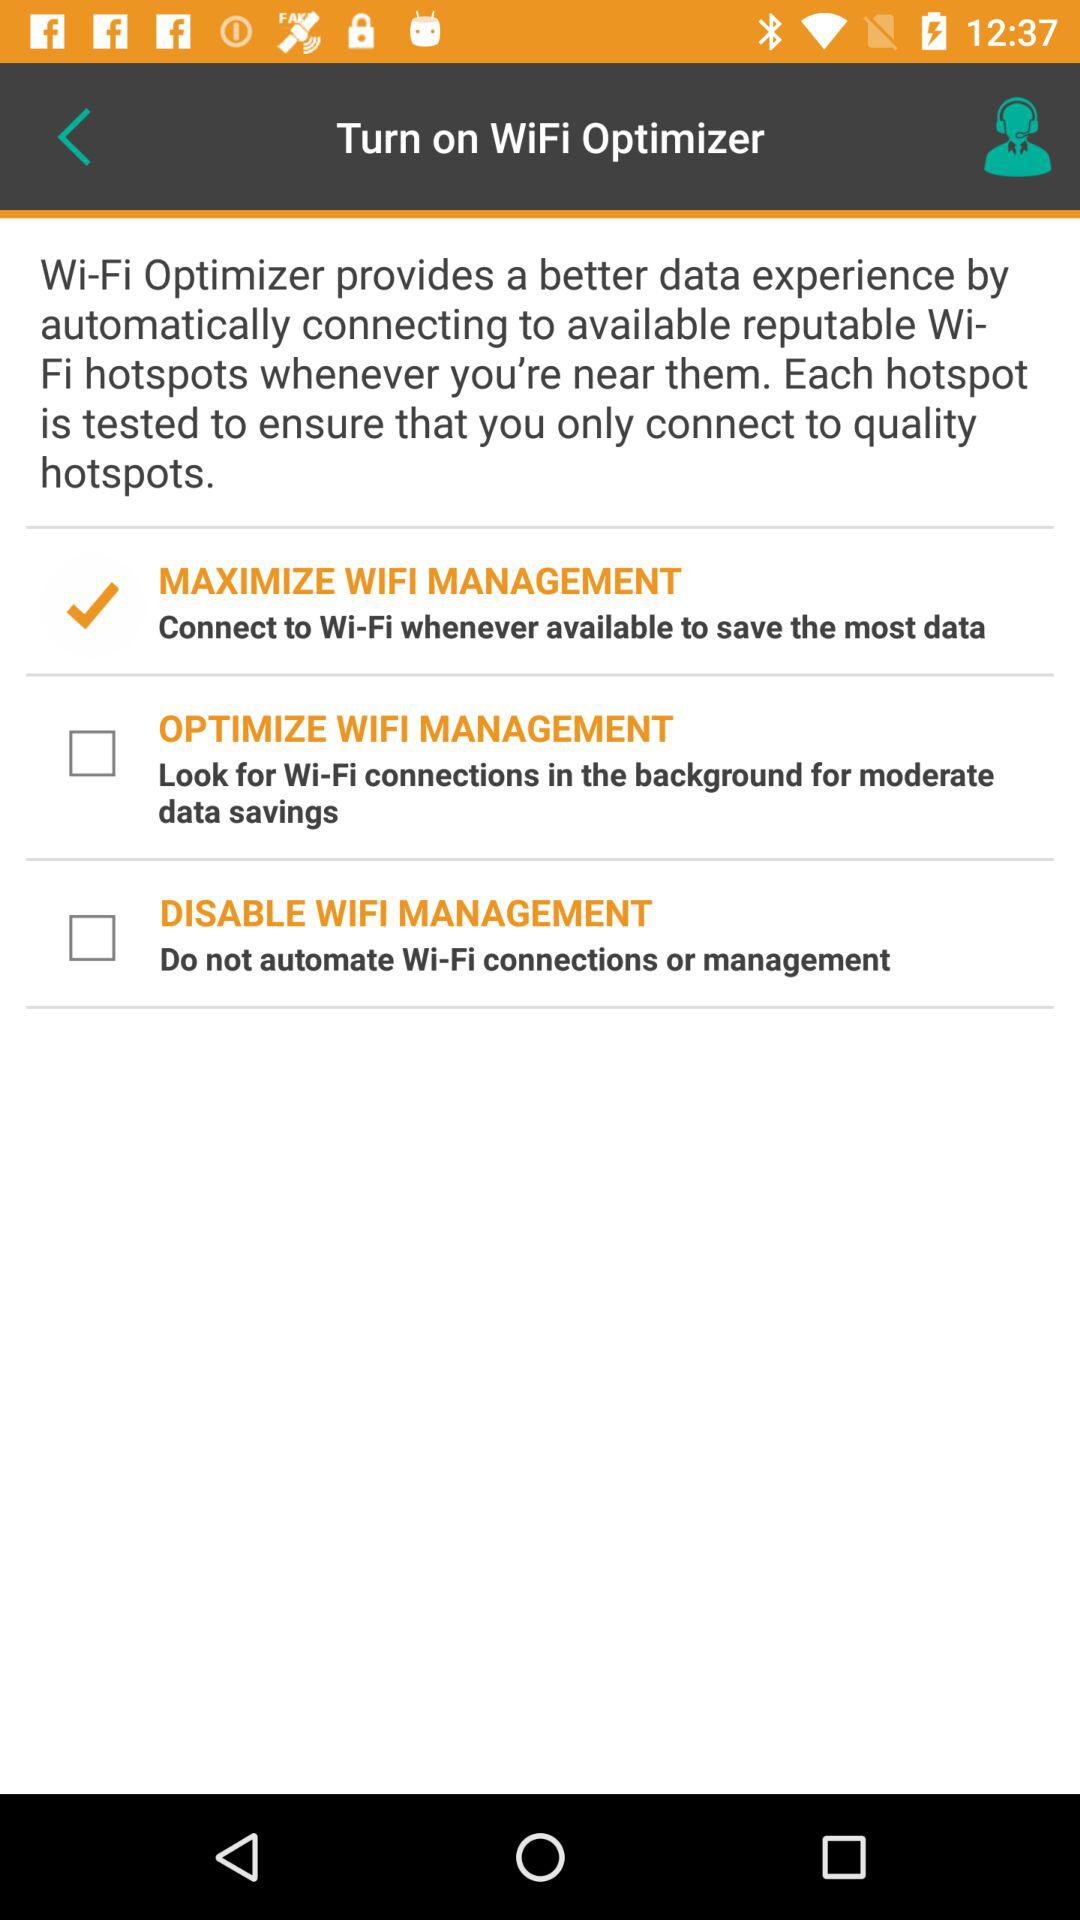Which option is checked? The checked option is "MAXIMIZE WIFI MANAGEMENT". 